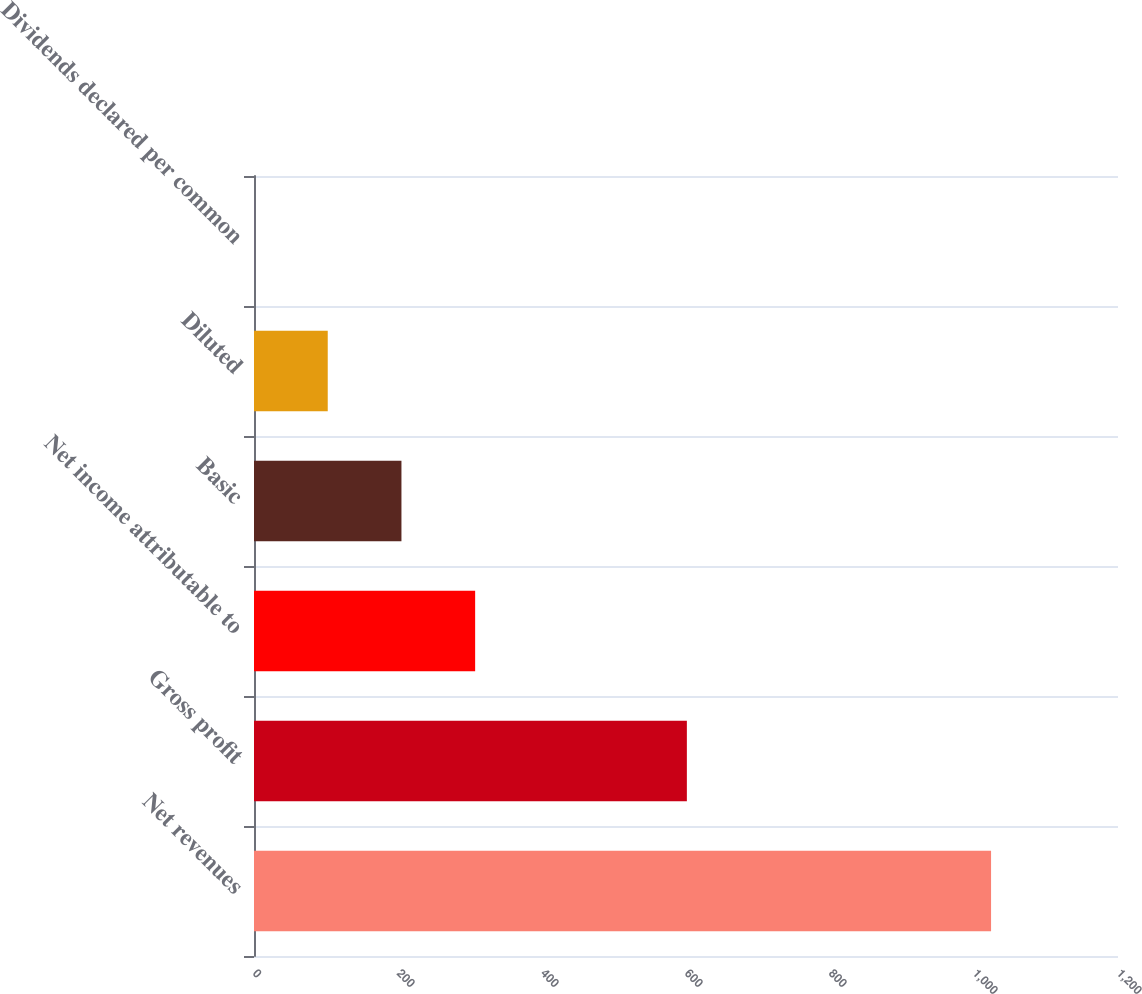Convert chart to OTSL. <chart><loc_0><loc_0><loc_500><loc_500><bar_chart><fcel>Net revenues<fcel>Gross profit<fcel>Net income attributable to<fcel>Basic<fcel>Diluted<fcel>Dividends declared per common<nl><fcel>1023.7<fcel>601.2<fcel>307.15<fcel>204.79<fcel>102.42<fcel>0.05<nl></chart> 